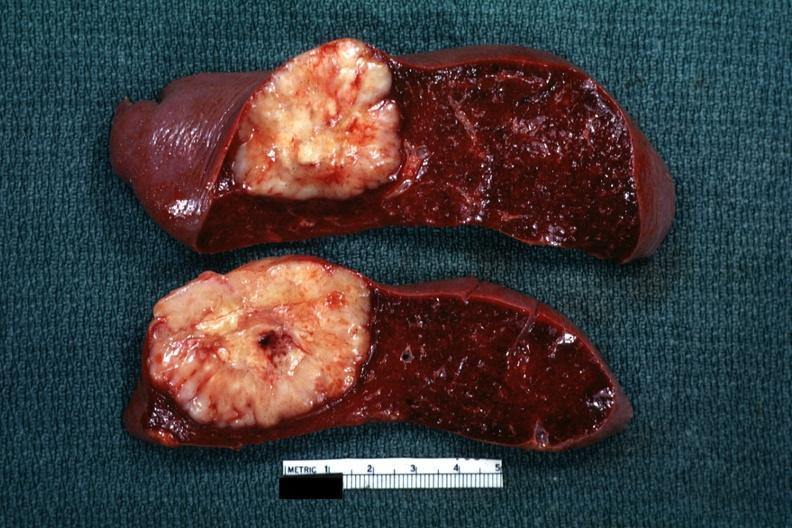what was diagnosis cell sarcoma?
Answer the question using a single word or phrase. Reticulum 